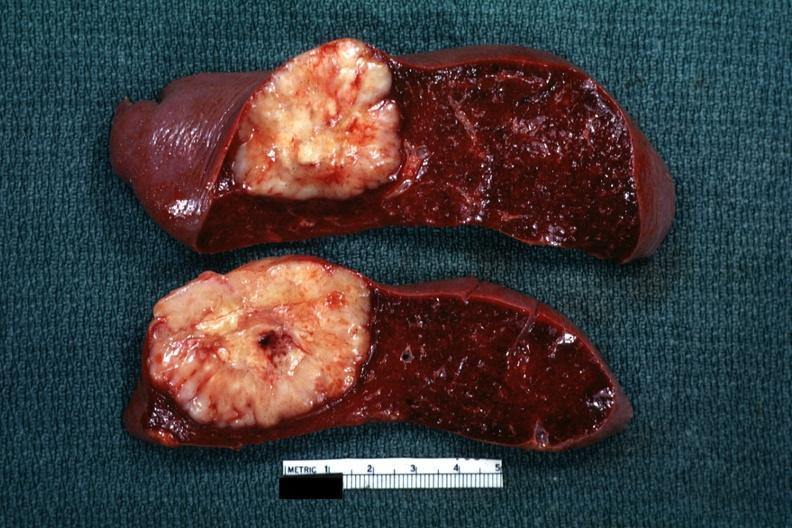what was diagnosis cell sarcoma?
Answer the question using a single word or phrase. Reticulum 